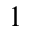<formula> <loc_0><loc_0><loc_500><loc_500>^ { 1 }</formula> 